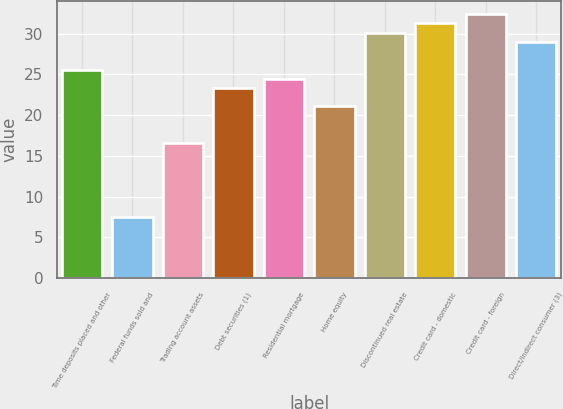<chart> <loc_0><loc_0><loc_500><loc_500><bar_chart><fcel>Time deposits placed and other<fcel>Federal funds sold and<fcel>Trading account assets<fcel>Debt securities (1)<fcel>Residential mortgage<fcel>Home equity<fcel>Discontinued real estate<fcel>Credit card - domestic<fcel>Credit card - foreign<fcel>Direct/Indirect consumer (3)<nl><fcel>25.59<fcel>7.51<fcel>16.55<fcel>23.33<fcel>24.46<fcel>21.07<fcel>30.11<fcel>31.24<fcel>32.37<fcel>28.98<nl></chart> 